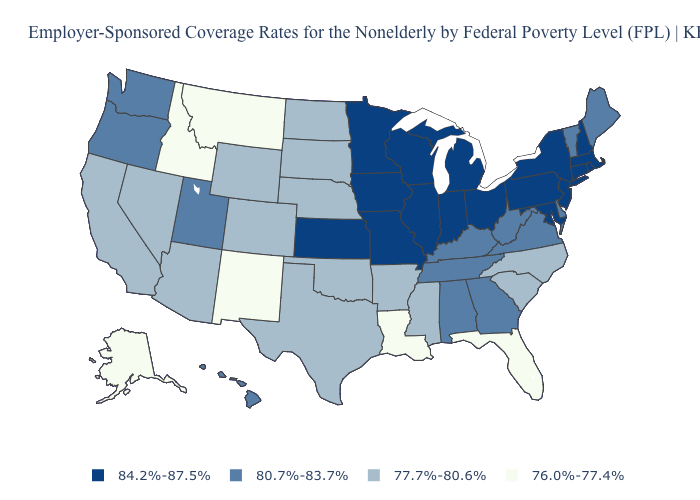Does New Hampshire have the highest value in the Northeast?
Answer briefly. Yes. How many symbols are there in the legend?
Be succinct. 4. Does Iowa have a higher value than Louisiana?
Short answer required. Yes. Name the states that have a value in the range 76.0%-77.4%?
Answer briefly. Alaska, Florida, Idaho, Louisiana, Montana, New Mexico. Does Alaska have the lowest value in the USA?
Keep it brief. Yes. Name the states that have a value in the range 80.7%-83.7%?
Write a very short answer. Alabama, Delaware, Georgia, Hawaii, Kentucky, Maine, Oregon, Tennessee, Utah, Vermont, Virginia, Washington, West Virginia. Name the states that have a value in the range 77.7%-80.6%?
Answer briefly. Arizona, Arkansas, California, Colorado, Mississippi, Nebraska, Nevada, North Carolina, North Dakota, Oklahoma, South Carolina, South Dakota, Texas, Wyoming. How many symbols are there in the legend?
Short answer required. 4. What is the value of Tennessee?
Quick response, please. 80.7%-83.7%. What is the value of Utah?
Answer briefly. 80.7%-83.7%. Name the states that have a value in the range 80.7%-83.7%?
Keep it brief. Alabama, Delaware, Georgia, Hawaii, Kentucky, Maine, Oregon, Tennessee, Utah, Vermont, Virginia, Washington, West Virginia. Name the states that have a value in the range 84.2%-87.5%?
Write a very short answer. Connecticut, Illinois, Indiana, Iowa, Kansas, Maryland, Massachusetts, Michigan, Minnesota, Missouri, New Hampshire, New Jersey, New York, Ohio, Pennsylvania, Rhode Island, Wisconsin. What is the value of Montana?
Concise answer only. 76.0%-77.4%. Name the states that have a value in the range 76.0%-77.4%?
Be succinct. Alaska, Florida, Idaho, Louisiana, Montana, New Mexico. Does South Carolina have a lower value than Connecticut?
Keep it brief. Yes. 